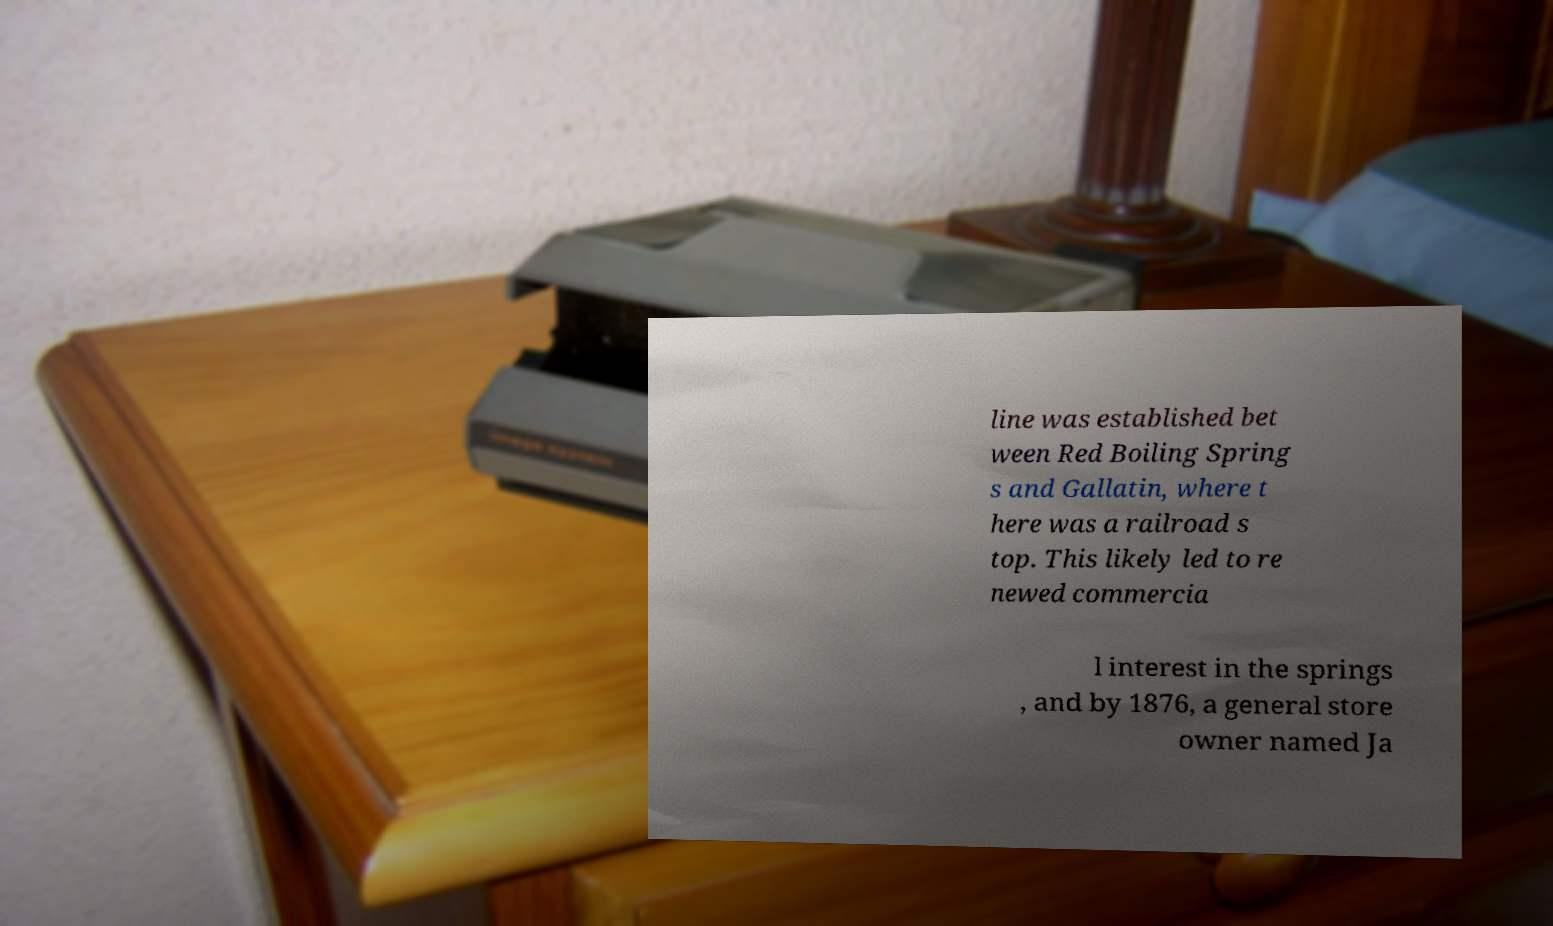Can you read and provide the text displayed in the image?This photo seems to have some interesting text. Can you extract and type it out for me? line was established bet ween Red Boiling Spring s and Gallatin, where t here was a railroad s top. This likely led to re newed commercia l interest in the springs , and by 1876, a general store owner named Ja 